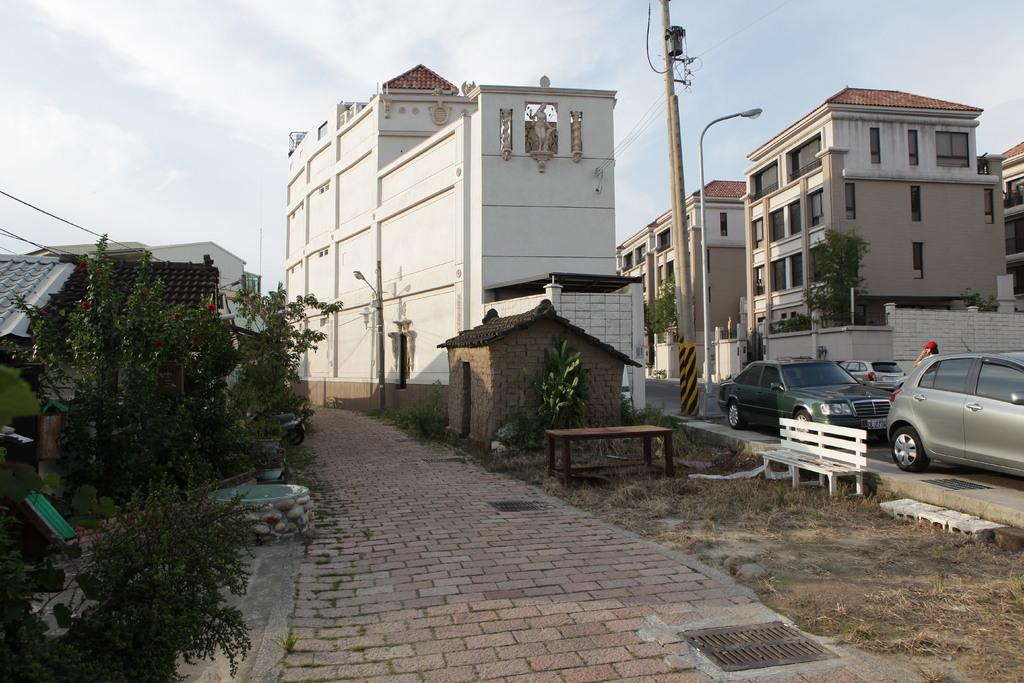How many buildings can be seen in the image? There are two buildings in the image. What else can be seen in the image besides the buildings? Two vehicles are parked beside the road in the image. What sense is being used by the buildings in the image? Buildings do not have senses, as they are inanimate objects. 